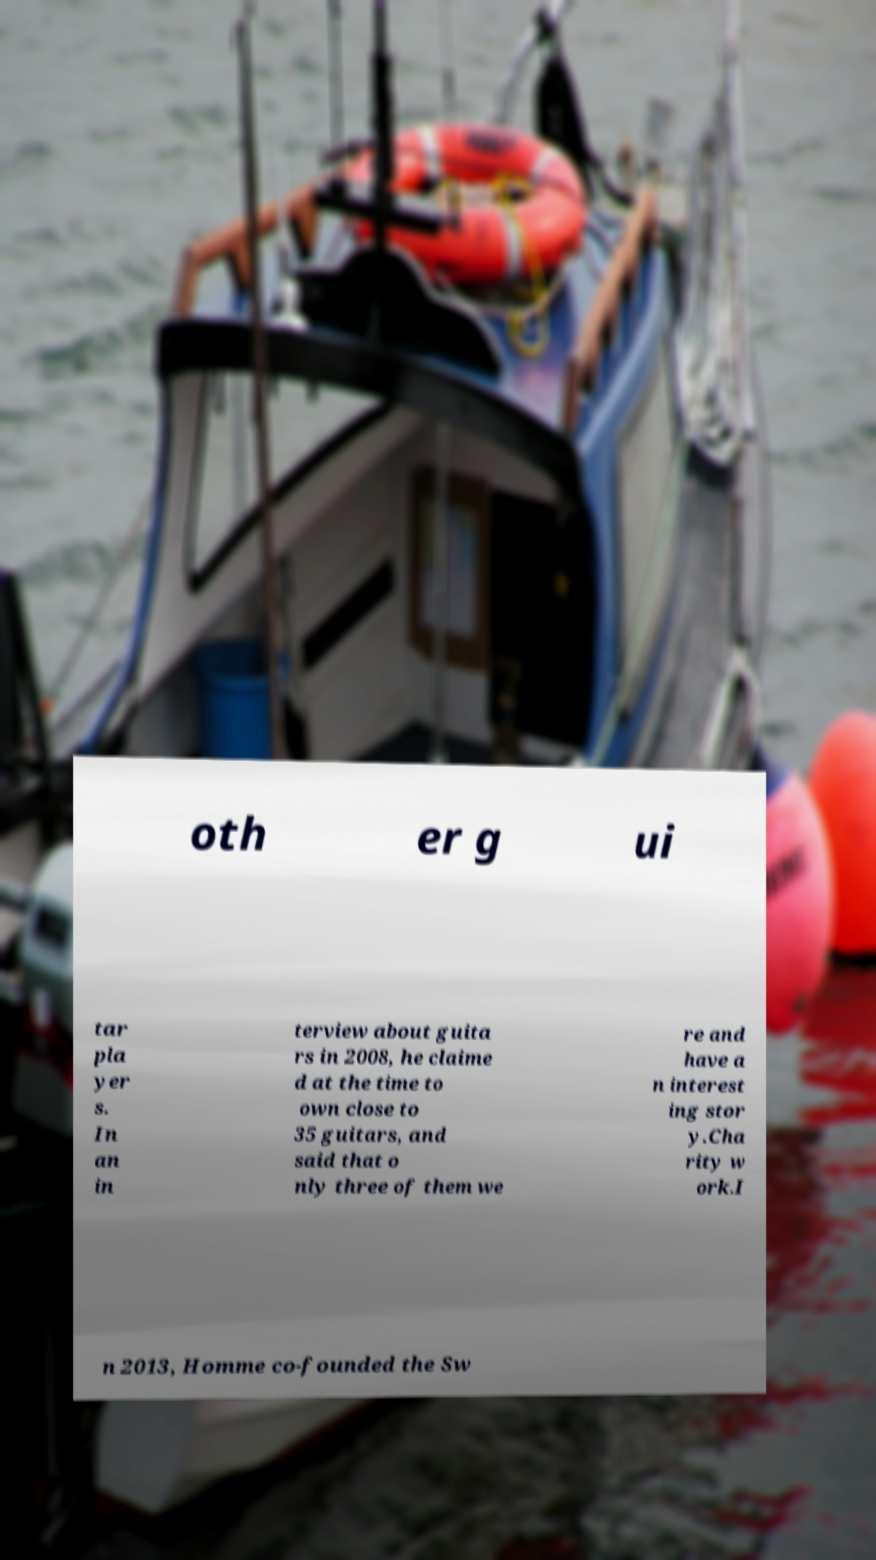I need the written content from this picture converted into text. Can you do that? oth er g ui tar pla yer s. In an in terview about guita rs in 2008, he claime d at the time to own close to 35 guitars, and said that o nly three of them we re and have a n interest ing stor y.Cha rity w ork.I n 2013, Homme co-founded the Sw 